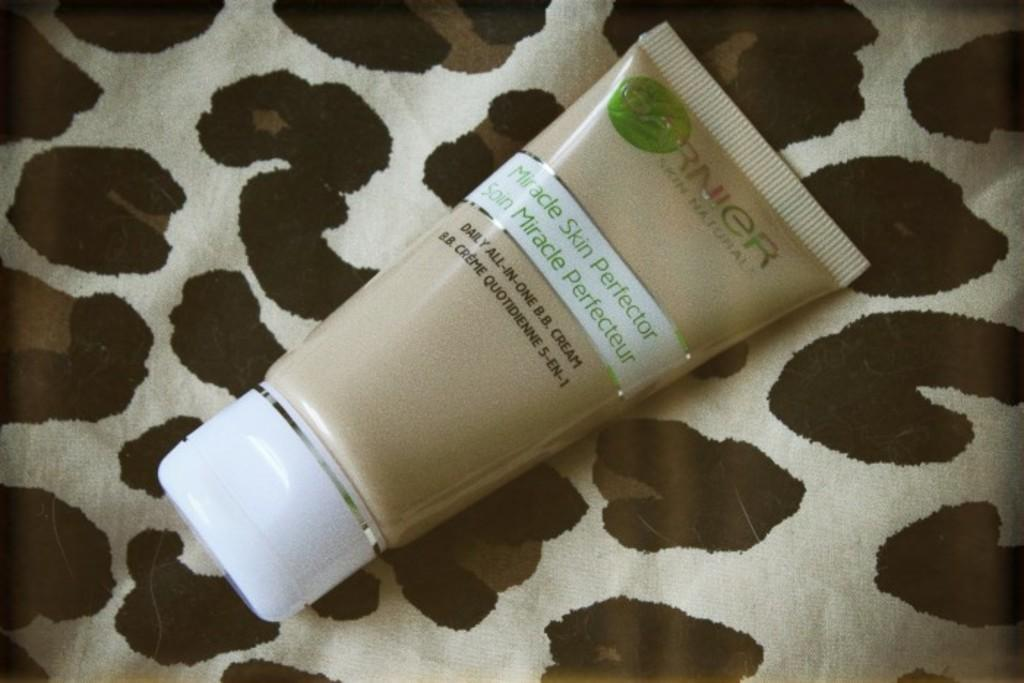Provide a one-sentence caption for the provided image. A tube of Garnier Miracle skin perfector on an animal print cloth. 